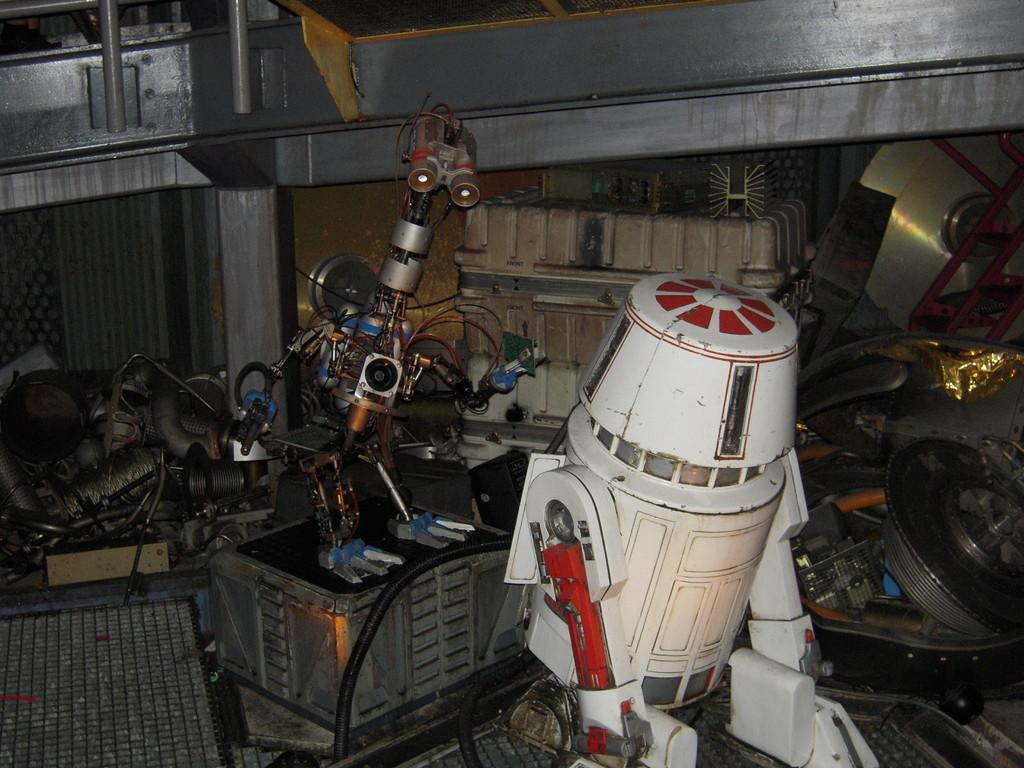What type of materials are the objects in the image made of? The objects in the image are made of plastic and metal. What color is the paint on the objects in the image? There is no paint present on the objects in the image; they are made of plastic and metal. 